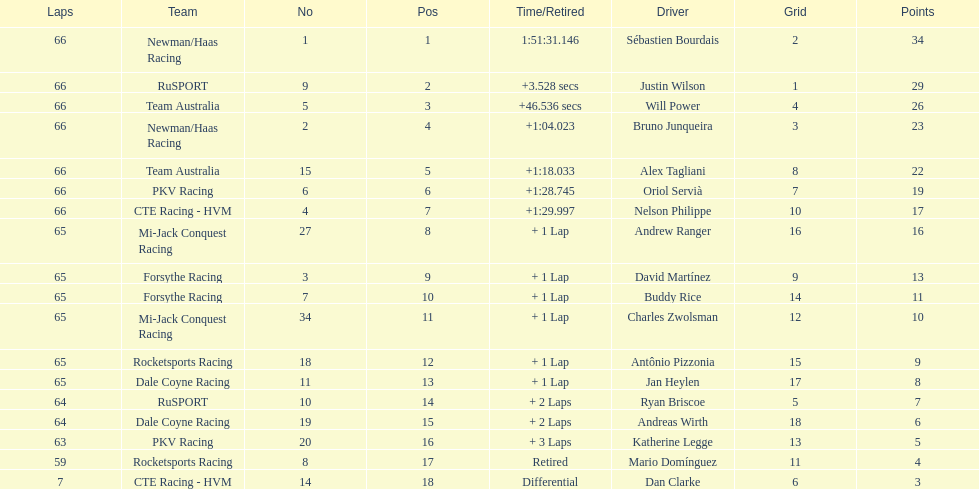Which driver has the same number as his/her position? Sébastien Bourdais. 